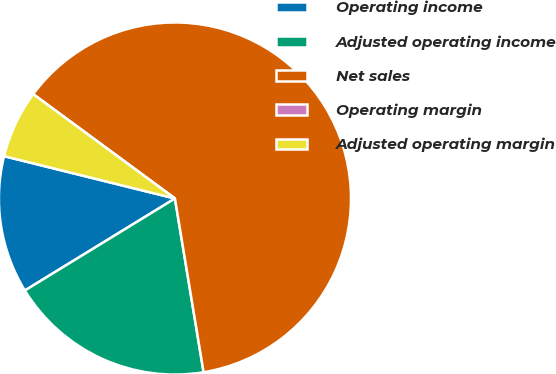Convert chart. <chart><loc_0><loc_0><loc_500><loc_500><pie_chart><fcel>Operating income<fcel>Adjusted operating income<fcel>Net sales<fcel>Operating margin<fcel>Adjusted operating margin<nl><fcel>12.62%<fcel>18.85%<fcel>62.3%<fcel>0.0%<fcel>6.23%<nl></chart> 